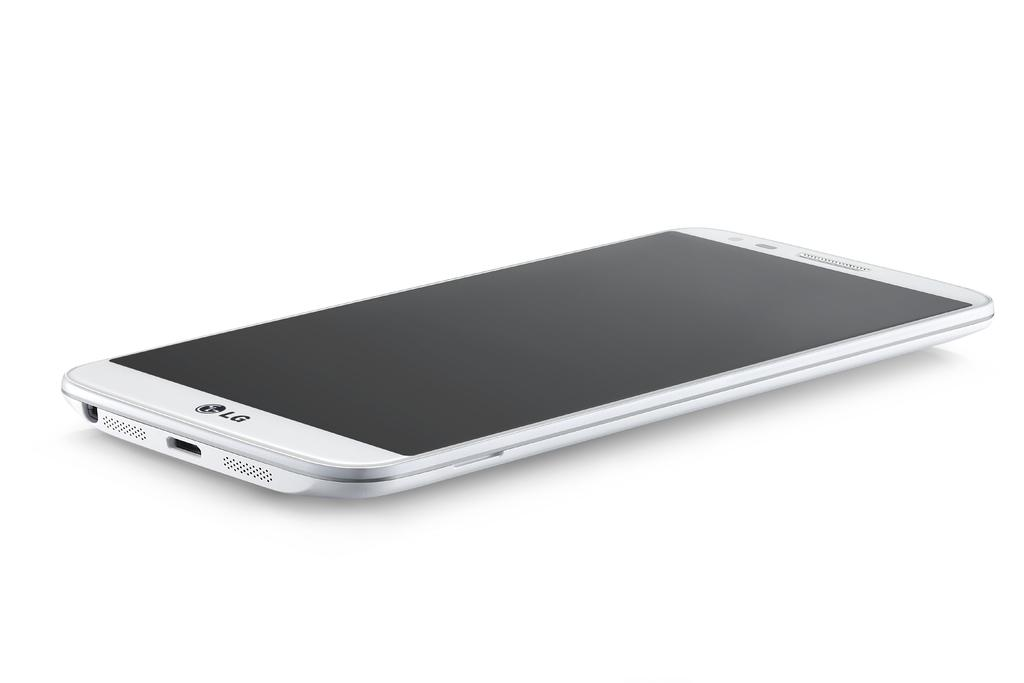<image>
Share a concise interpretation of the image provided. A slim, white LG cell phone laying right side up. 